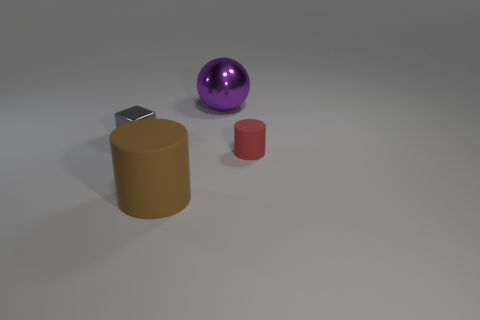There is a large object in front of the small shiny block; what color is it?
Offer a very short reply. Brown. There is a rubber cylinder on the left side of the large thing behind the tiny gray block; what number of objects are to the right of it?
Your response must be concise. 2. The gray shiny cube is what size?
Your answer should be compact. Small. What is the material of the brown thing that is the same size as the purple sphere?
Give a very brief answer. Rubber. There is a big cylinder; what number of large cylinders are behind it?
Your answer should be compact. 0. Is the small object on the right side of the tiny gray object made of the same material as the tiny thing on the left side of the purple thing?
Provide a succinct answer. No. What shape is the large thing that is behind the small thing that is on the right side of the rubber thing that is on the left side of the purple metal sphere?
Give a very brief answer. Sphere. What is the shape of the small red rubber object?
Offer a terse response. Cylinder. There is a object that is the same size as the red cylinder; what shape is it?
Ensure brevity in your answer.  Cube. Do the small object right of the purple metallic ball and the shiny object that is right of the small gray object have the same shape?
Your answer should be very brief. No. 